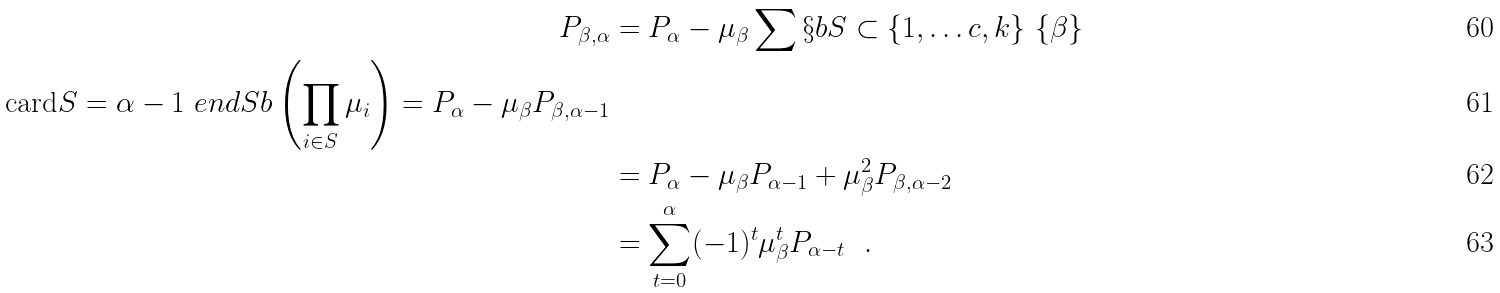<formula> <loc_0><loc_0><loc_500><loc_500>P _ { \beta , \alpha } & = P _ { \alpha } - \mu _ { \beta } \sum \S b S \subset \{ 1 , \dots c , k \} \ \{ \beta \} \\ \text {card} S = \alpha - 1 \ e n d S b \left ( \prod _ { i \in S } \mu _ { i } \right ) = P _ { \alpha } - \mu _ { \beta } P _ { \beta , \alpha - 1 } \\ & = P _ { \alpha } - \mu _ { \beta } P _ { \alpha - 1 } + \mu _ { \beta } ^ { 2 } P _ { \beta , \alpha - 2 } \\ & = \sum ^ { \alpha } _ { t = 0 } ( - 1 ) ^ { t } \mu _ { \beta } ^ { t } P _ { \alpha - t } \ \ .</formula> 